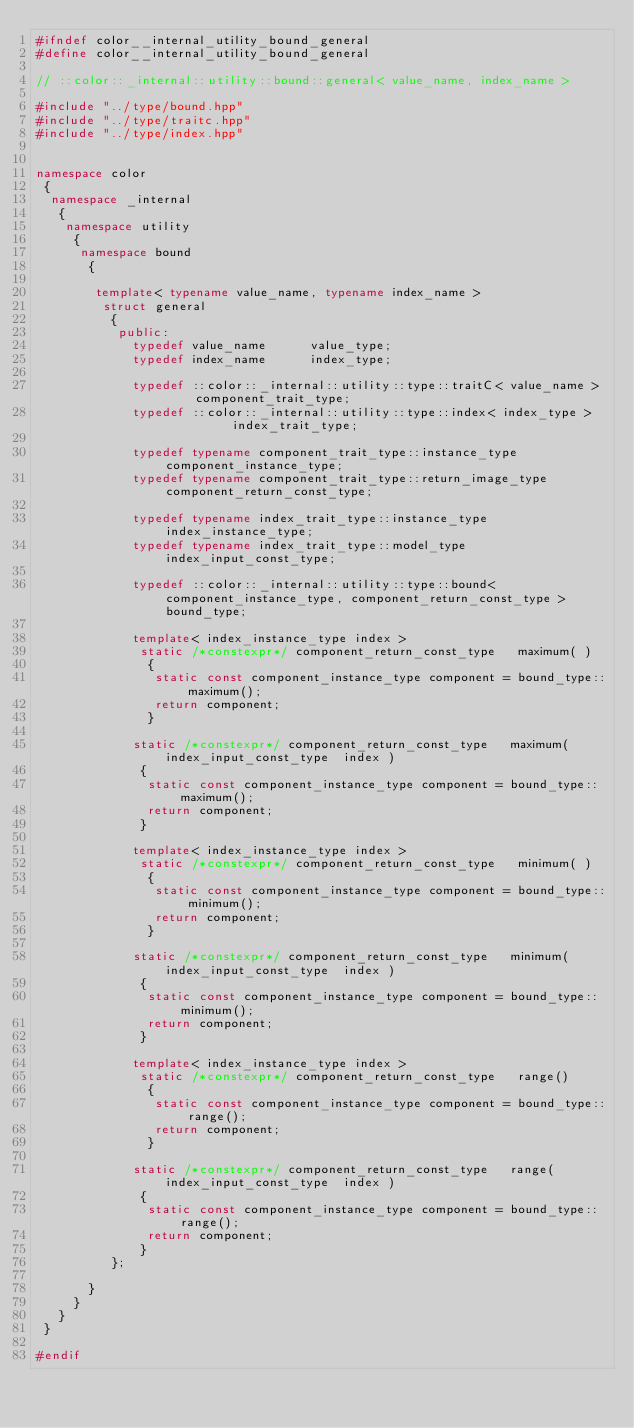Convert code to text. <code><loc_0><loc_0><loc_500><loc_500><_C++_>#ifndef color__internal_utility_bound_general
#define color__internal_utility_bound_general

// ::color::_internal::utility::bound::general< value_name, index_name >

#include "../type/bound.hpp"
#include "../type/traitc.hpp"
#include "../type/index.hpp"


namespace color
 {
  namespace _internal
   {
    namespace utility
     {
      namespace bound
       {

        template< typename value_name, typename index_name >
         struct general
          {
           public:
             typedef value_name      value_type;
             typedef index_name      index_type;

             typedef ::color::_internal::utility::type::traitC< value_name >     component_trait_type;
             typedef ::color::_internal::utility::type::index< index_type >          index_trait_type;

             typedef typename component_trait_type::instance_type      component_instance_type;
             typedef typename component_trait_type::return_image_type  component_return_const_type;
             
             typedef typename index_trait_type::instance_type    index_instance_type;
             typedef typename index_trait_type::model_type index_input_const_type;

             typedef ::color::_internal::utility::type::bound< component_instance_type, component_return_const_type > bound_type;

             template< index_instance_type index >
              static /*constexpr*/ component_return_const_type   maximum( )
               {
                static const component_instance_type component = bound_type::maximum();
                return component;
               }

             static /*constexpr*/ component_return_const_type   maximum( index_input_const_type  index )
              {
               static const component_instance_type component = bound_type::maximum();
               return component;
              }

             template< index_instance_type index >
              static /*constexpr*/ component_return_const_type   minimum( )
               {
                static const component_instance_type component = bound_type::minimum();
                return component;
               }

             static /*constexpr*/ component_return_const_type   minimum( index_input_const_type  index )
              {
               static const component_instance_type component = bound_type::minimum();
               return component;
              }

             template< index_instance_type index >
              static /*constexpr*/ component_return_const_type   range()
               {
                static const component_instance_type component = bound_type::range();
                return component;
               }

             static /*constexpr*/ component_return_const_type   range(   index_input_const_type  index )
              {
               static const component_instance_type component = bound_type::range();
               return component;
              }
          };

       }
     }
   }
 }

#endif
</code> 